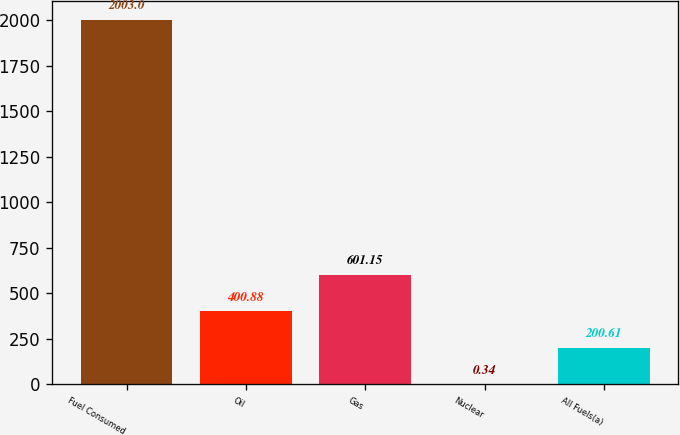Convert chart. <chart><loc_0><loc_0><loc_500><loc_500><bar_chart><fcel>Fuel Consumed<fcel>Oil<fcel>Gas<fcel>Nuclear<fcel>All Fuels(a)<nl><fcel>2003<fcel>400.88<fcel>601.15<fcel>0.34<fcel>200.61<nl></chart> 